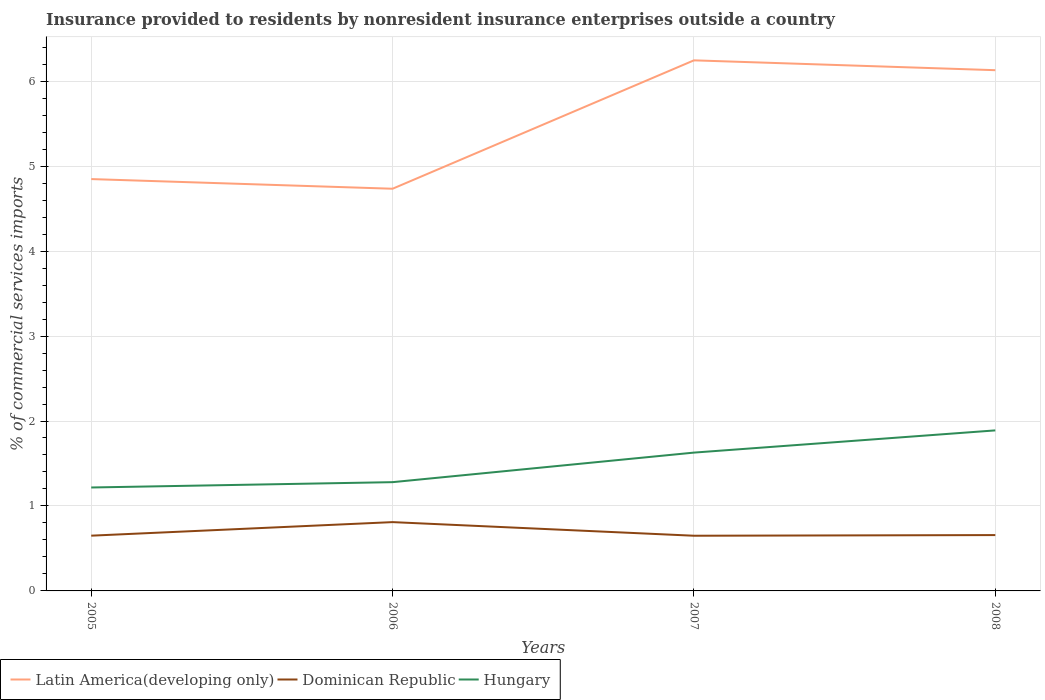Does the line corresponding to Dominican Republic intersect with the line corresponding to Hungary?
Make the answer very short. No. Is the number of lines equal to the number of legend labels?
Your response must be concise. Yes. Across all years, what is the maximum Insurance provided to residents in Hungary?
Your response must be concise. 1.22. What is the total Insurance provided to residents in Dominican Republic in the graph?
Give a very brief answer. -0.01. What is the difference between the highest and the second highest Insurance provided to residents in Latin America(developing only)?
Your answer should be compact. 1.51. How many years are there in the graph?
Offer a very short reply. 4. Does the graph contain any zero values?
Your answer should be very brief. No. Does the graph contain grids?
Your answer should be very brief. Yes. Where does the legend appear in the graph?
Offer a terse response. Bottom left. How many legend labels are there?
Your answer should be very brief. 3. How are the legend labels stacked?
Your answer should be compact. Horizontal. What is the title of the graph?
Ensure brevity in your answer.  Insurance provided to residents by nonresident insurance enterprises outside a country. Does "India" appear as one of the legend labels in the graph?
Provide a succinct answer. No. What is the label or title of the X-axis?
Offer a very short reply. Years. What is the label or title of the Y-axis?
Provide a succinct answer. % of commercial services imports. What is the % of commercial services imports of Latin America(developing only) in 2005?
Your answer should be very brief. 4.85. What is the % of commercial services imports in Dominican Republic in 2005?
Provide a short and direct response. 0.65. What is the % of commercial services imports in Hungary in 2005?
Ensure brevity in your answer.  1.22. What is the % of commercial services imports in Latin America(developing only) in 2006?
Offer a very short reply. 4.73. What is the % of commercial services imports in Dominican Republic in 2006?
Provide a short and direct response. 0.81. What is the % of commercial services imports in Hungary in 2006?
Offer a very short reply. 1.28. What is the % of commercial services imports of Latin America(developing only) in 2007?
Provide a short and direct response. 6.25. What is the % of commercial services imports in Dominican Republic in 2007?
Provide a short and direct response. 0.65. What is the % of commercial services imports in Hungary in 2007?
Your answer should be compact. 1.63. What is the % of commercial services imports of Latin America(developing only) in 2008?
Offer a terse response. 6.13. What is the % of commercial services imports in Dominican Republic in 2008?
Provide a short and direct response. 0.66. What is the % of commercial services imports of Hungary in 2008?
Ensure brevity in your answer.  1.89. Across all years, what is the maximum % of commercial services imports of Latin America(developing only)?
Your answer should be very brief. 6.25. Across all years, what is the maximum % of commercial services imports in Dominican Republic?
Offer a very short reply. 0.81. Across all years, what is the maximum % of commercial services imports of Hungary?
Your answer should be very brief. 1.89. Across all years, what is the minimum % of commercial services imports of Latin America(developing only)?
Provide a succinct answer. 4.73. Across all years, what is the minimum % of commercial services imports of Dominican Republic?
Ensure brevity in your answer.  0.65. Across all years, what is the minimum % of commercial services imports in Hungary?
Provide a short and direct response. 1.22. What is the total % of commercial services imports of Latin America(developing only) in the graph?
Give a very brief answer. 21.96. What is the total % of commercial services imports of Dominican Republic in the graph?
Keep it short and to the point. 2.77. What is the total % of commercial services imports of Hungary in the graph?
Ensure brevity in your answer.  6.02. What is the difference between the % of commercial services imports of Latin America(developing only) in 2005 and that in 2006?
Provide a short and direct response. 0.11. What is the difference between the % of commercial services imports of Dominican Republic in 2005 and that in 2006?
Your answer should be very brief. -0.16. What is the difference between the % of commercial services imports in Hungary in 2005 and that in 2006?
Ensure brevity in your answer.  -0.06. What is the difference between the % of commercial services imports of Latin America(developing only) in 2005 and that in 2007?
Provide a short and direct response. -1.4. What is the difference between the % of commercial services imports in Dominican Republic in 2005 and that in 2007?
Your response must be concise. 0. What is the difference between the % of commercial services imports in Hungary in 2005 and that in 2007?
Offer a terse response. -0.41. What is the difference between the % of commercial services imports of Latin America(developing only) in 2005 and that in 2008?
Offer a very short reply. -1.28. What is the difference between the % of commercial services imports of Dominican Republic in 2005 and that in 2008?
Provide a short and direct response. -0.01. What is the difference between the % of commercial services imports of Hungary in 2005 and that in 2008?
Ensure brevity in your answer.  -0.67. What is the difference between the % of commercial services imports of Latin America(developing only) in 2006 and that in 2007?
Your answer should be very brief. -1.51. What is the difference between the % of commercial services imports of Dominican Republic in 2006 and that in 2007?
Provide a succinct answer. 0.16. What is the difference between the % of commercial services imports of Hungary in 2006 and that in 2007?
Offer a very short reply. -0.35. What is the difference between the % of commercial services imports of Latin America(developing only) in 2006 and that in 2008?
Keep it short and to the point. -1.4. What is the difference between the % of commercial services imports of Dominican Republic in 2006 and that in 2008?
Your response must be concise. 0.15. What is the difference between the % of commercial services imports of Hungary in 2006 and that in 2008?
Your response must be concise. -0.61. What is the difference between the % of commercial services imports of Latin America(developing only) in 2007 and that in 2008?
Your answer should be very brief. 0.12. What is the difference between the % of commercial services imports in Dominican Republic in 2007 and that in 2008?
Provide a short and direct response. -0.01. What is the difference between the % of commercial services imports of Hungary in 2007 and that in 2008?
Offer a very short reply. -0.26. What is the difference between the % of commercial services imports in Latin America(developing only) in 2005 and the % of commercial services imports in Dominican Republic in 2006?
Ensure brevity in your answer.  4.04. What is the difference between the % of commercial services imports of Latin America(developing only) in 2005 and the % of commercial services imports of Hungary in 2006?
Keep it short and to the point. 3.57. What is the difference between the % of commercial services imports of Dominican Republic in 2005 and the % of commercial services imports of Hungary in 2006?
Provide a short and direct response. -0.63. What is the difference between the % of commercial services imports of Latin America(developing only) in 2005 and the % of commercial services imports of Dominican Republic in 2007?
Your answer should be very brief. 4.2. What is the difference between the % of commercial services imports in Latin America(developing only) in 2005 and the % of commercial services imports in Hungary in 2007?
Offer a terse response. 3.22. What is the difference between the % of commercial services imports of Dominican Republic in 2005 and the % of commercial services imports of Hungary in 2007?
Offer a very short reply. -0.98. What is the difference between the % of commercial services imports of Latin America(developing only) in 2005 and the % of commercial services imports of Dominican Republic in 2008?
Give a very brief answer. 4.19. What is the difference between the % of commercial services imports in Latin America(developing only) in 2005 and the % of commercial services imports in Hungary in 2008?
Your answer should be compact. 2.96. What is the difference between the % of commercial services imports in Dominican Republic in 2005 and the % of commercial services imports in Hungary in 2008?
Give a very brief answer. -1.24. What is the difference between the % of commercial services imports of Latin America(developing only) in 2006 and the % of commercial services imports of Dominican Republic in 2007?
Your answer should be compact. 4.08. What is the difference between the % of commercial services imports in Latin America(developing only) in 2006 and the % of commercial services imports in Hungary in 2007?
Make the answer very short. 3.11. What is the difference between the % of commercial services imports of Dominican Republic in 2006 and the % of commercial services imports of Hungary in 2007?
Offer a terse response. -0.82. What is the difference between the % of commercial services imports in Latin America(developing only) in 2006 and the % of commercial services imports in Dominican Republic in 2008?
Provide a succinct answer. 4.08. What is the difference between the % of commercial services imports of Latin America(developing only) in 2006 and the % of commercial services imports of Hungary in 2008?
Your response must be concise. 2.84. What is the difference between the % of commercial services imports of Dominican Republic in 2006 and the % of commercial services imports of Hungary in 2008?
Make the answer very short. -1.08. What is the difference between the % of commercial services imports of Latin America(developing only) in 2007 and the % of commercial services imports of Dominican Republic in 2008?
Keep it short and to the point. 5.59. What is the difference between the % of commercial services imports in Latin America(developing only) in 2007 and the % of commercial services imports in Hungary in 2008?
Your answer should be very brief. 4.36. What is the difference between the % of commercial services imports in Dominican Republic in 2007 and the % of commercial services imports in Hungary in 2008?
Your response must be concise. -1.24. What is the average % of commercial services imports of Latin America(developing only) per year?
Ensure brevity in your answer.  5.49. What is the average % of commercial services imports in Dominican Republic per year?
Provide a succinct answer. 0.69. What is the average % of commercial services imports of Hungary per year?
Ensure brevity in your answer.  1.5. In the year 2005, what is the difference between the % of commercial services imports of Latin America(developing only) and % of commercial services imports of Dominican Republic?
Offer a terse response. 4.2. In the year 2005, what is the difference between the % of commercial services imports in Latin America(developing only) and % of commercial services imports in Hungary?
Make the answer very short. 3.63. In the year 2005, what is the difference between the % of commercial services imports of Dominican Republic and % of commercial services imports of Hungary?
Give a very brief answer. -0.57. In the year 2006, what is the difference between the % of commercial services imports in Latin America(developing only) and % of commercial services imports in Dominican Republic?
Your answer should be very brief. 3.92. In the year 2006, what is the difference between the % of commercial services imports in Latin America(developing only) and % of commercial services imports in Hungary?
Offer a very short reply. 3.45. In the year 2006, what is the difference between the % of commercial services imports in Dominican Republic and % of commercial services imports in Hungary?
Offer a terse response. -0.47. In the year 2007, what is the difference between the % of commercial services imports of Latin America(developing only) and % of commercial services imports of Dominican Republic?
Your answer should be compact. 5.6. In the year 2007, what is the difference between the % of commercial services imports of Latin America(developing only) and % of commercial services imports of Hungary?
Make the answer very short. 4.62. In the year 2007, what is the difference between the % of commercial services imports of Dominican Republic and % of commercial services imports of Hungary?
Your answer should be very brief. -0.98. In the year 2008, what is the difference between the % of commercial services imports of Latin America(developing only) and % of commercial services imports of Dominican Republic?
Give a very brief answer. 5.47. In the year 2008, what is the difference between the % of commercial services imports in Latin America(developing only) and % of commercial services imports in Hungary?
Give a very brief answer. 4.24. In the year 2008, what is the difference between the % of commercial services imports in Dominican Republic and % of commercial services imports in Hungary?
Your answer should be compact. -1.23. What is the ratio of the % of commercial services imports in Dominican Republic in 2005 to that in 2006?
Your answer should be compact. 0.8. What is the ratio of the % of commercial services imports of Hungary in 2005 to that in 2006?
Offer a terse response. 0.95. What is the ratio of the % of commercial services imports in Latin America(developing only) in 2005 to that in 2007?
Your answer should be very brief. 0.78. What is the ratio of the % of commercial services imports of Hungary in 2005 to that in 2007?
Your response must be concise. 0.75. What is the ratio of the % of commercial services imports of Latin America(developing only) in 2005 to that in 2008?
Make the answer very short. 0.79. What is the ratio of the % of commercial services imports in Hungary in 2005 to that in 2008?
Your response must be concise. 0.64. What is the ratio of the % of commercial services imports of Latin America(developing only) in 2006 to that in 2007?
Offer a terse response. 0.76. What is the ratio of the % of commercial services imports of Dominican Republic in 2006 to that in 2007?
Make the answer very short. 1.25. What is the ratio of the % of commercial services imports in Hungary in 2006 to that in 2007?
Give a very brief answer. 0.79. What is the ratio of the % of commercial services imports in Latin America(developing only) in 2006 to that in 2008?
Keep it short and to the point. 0.77. What is the ratio of the % of commercial services imports of Dominican Republic in 2006 to that in 2008?
Provide a short and direct response. 1.23. What is the ratio of the % of commercial services imports of Hungary in 2006 to that in 2008?
Ensure brevity in your answer.  0.68. What is the ratio of the % of commercial services imports in Latin America(developing only) in 2007 to that in 2008?
Make the answer very short. 1.02. What is the ratio of the % of commercial services imports of Dominican Republic in 2007 to that in 2008?
Give a very brief answer. 0.99. What is the ratio of the % of commercial services imports of Hungary in 2007 to that in 2008?
Your response must be concise. 0.86. What is the difference between the highest and the second highest % of commercial services imports in Latin America(developing only)?
Ensure brevity in your answer.  0.12. What is the difference between the highest and the second highest % of commercial services imports in Dominican Republic?
Make the answer very short. 0.15. What is the difference between the highest and the second highest % of commercial services imports of Hungary?
Give a very brief answer. 0.26. What is the difference between the highest and the lowest % of commercial services imports in Latin America(developing only)?
Give a very brief answer. 1.51. What is the difference between the highest and the lowest % of commercial services imports in Dominican Republic?
Keep it short and to the point. 0.16. What is the difference between the highest and the lowest % of commercial services imports of Hungary?
Ensure brevity in your answer.  0.67. 